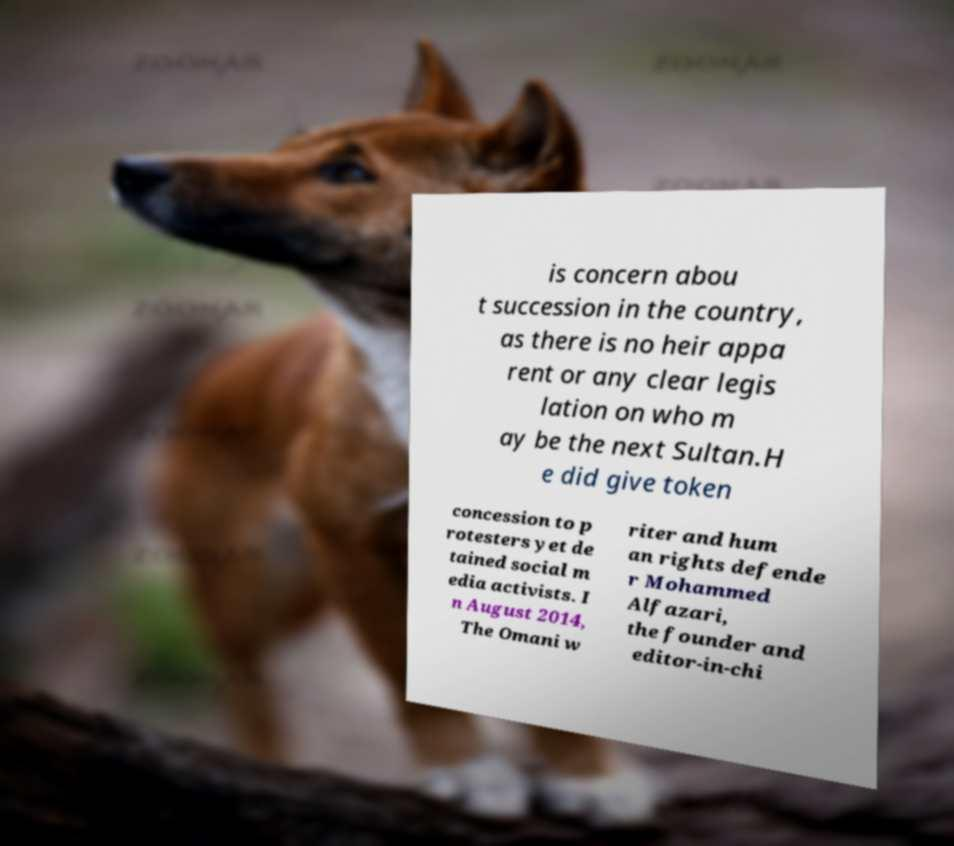What messages or text are displayed in this image? I need them in a readable, typed format. is concern abou t succession in the country, as there is no heir appa rent or any clear legis lation on who m ay be the next Sultan.H e did give token concession to p rotesters yet de tained social m edia activists. I n August 2014, The Omani w riter and hum an rights defende r Mohammed Alfazari, the founder and editor-in-chi 